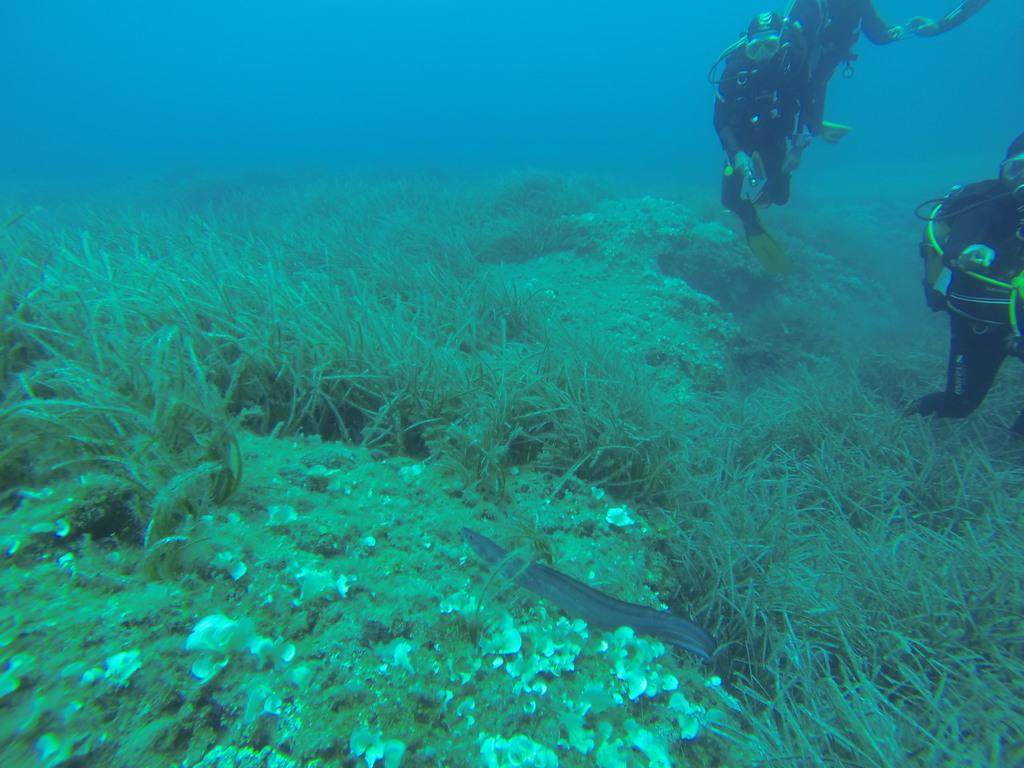What type of environment is depicted in the image? The image depicts a scene underwater. What can be seen on the rock surface in the image? There are plants visible on the rock surface in the image. What type of marine life is present in the image? There is a fish in the image. How many deep underwater is the scene taking place? The presence of three deep sea divers in the image suggests that the scene is taking place at a considerable depth. What equipment are the divers wearing in the image? The divers are wearing jackets and oxygen masks in the image. What type of pipe can be seen in the hands of the divers in the image? There are no pipes visible in the hands of the divers in the image. Can you tell me how many uncles are present in the image? There are no uncles present in the image; it depicts a scene underwater with divers and marine life. 